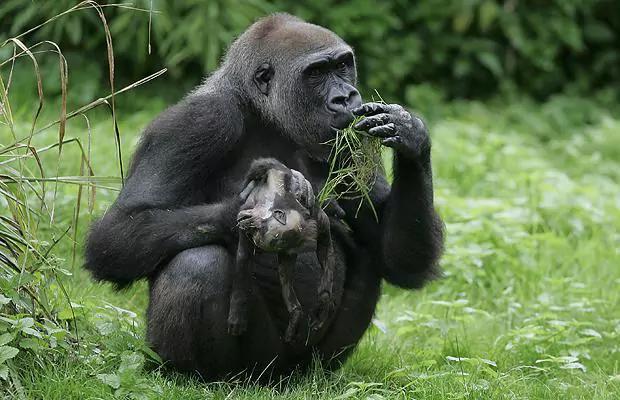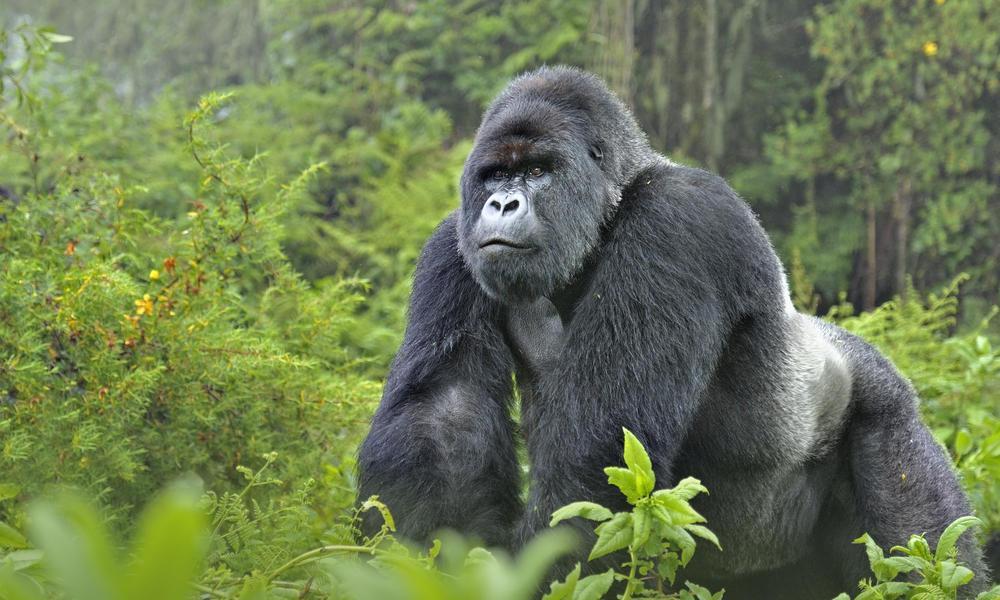The first image is the image on the left, the second image is the image on the right. Given the left and right images, does the statement "One image shows just one gorilla, a male on all fours with its body turned leftward, and the other image contains two apes, one a tiny baby." hold true? Answer yes or no. Yes. The first image is the image on the left, the second image is the image on the right. Analyze the images presented: Is the assertion "One primate is carrying a younger primate." valid? Answer yes or no. Yes. 